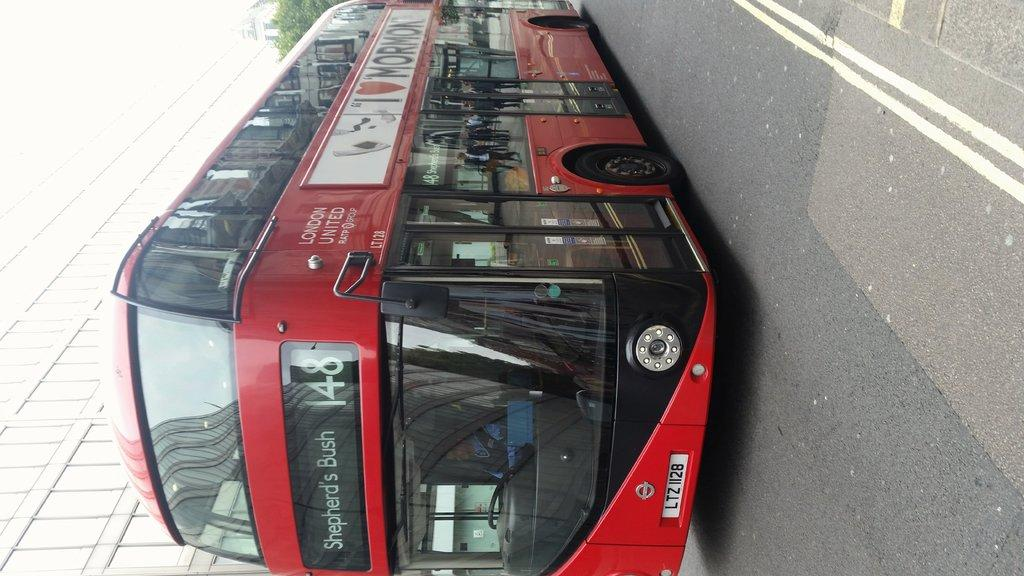What type of vehicle is in the image? There is a red color bus in the image. Where is the bus located? The bus is on the road. What can be seen to the left side of the image? There is a building to the left side of the image. What other object is present in the image? There is a tree in the image. Can you tell me where my mom is in the image? There is no information about your mom in the image, as it only features a red color bus, a building, a tree, and the road. 